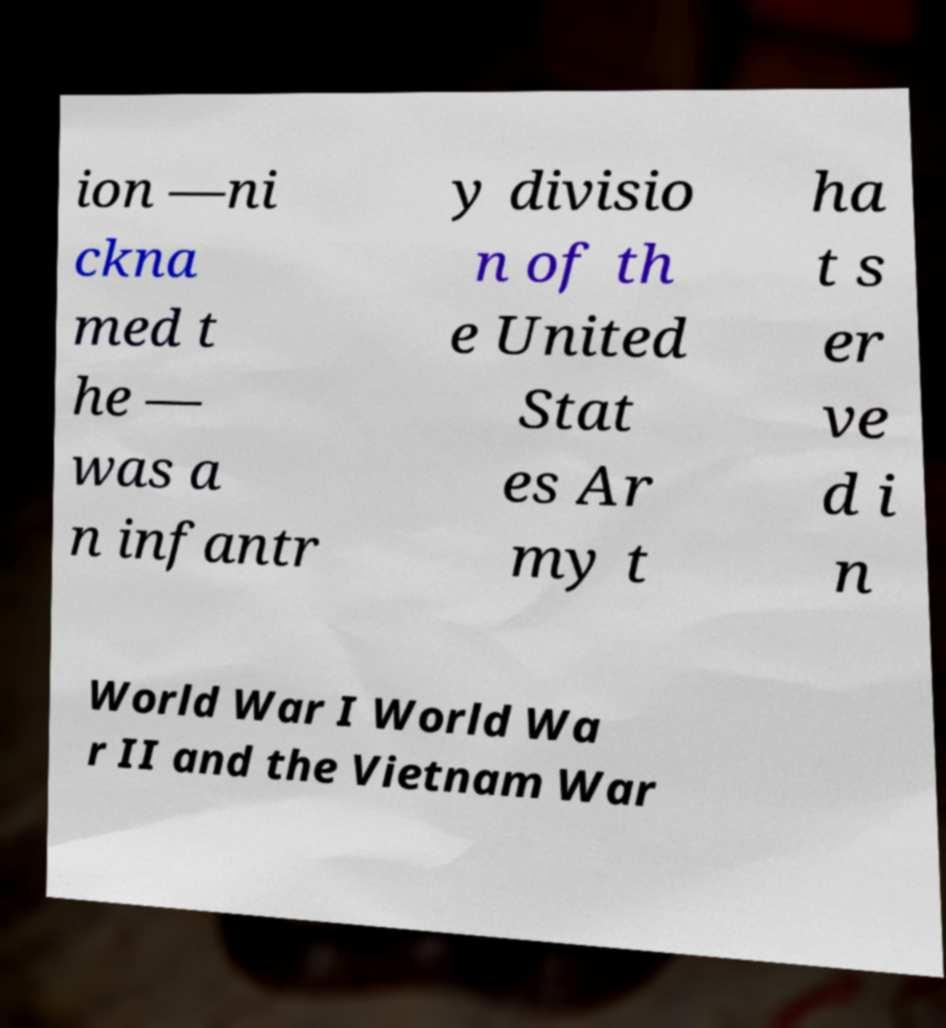Can you accurately transcribe the text from the provided image for me? ion —ni ckna med t he — was a n infantr y divisio n of th e United Stat es Ar my t ha t s er ve d i n World War I World Wa r II and the Vietnam War 